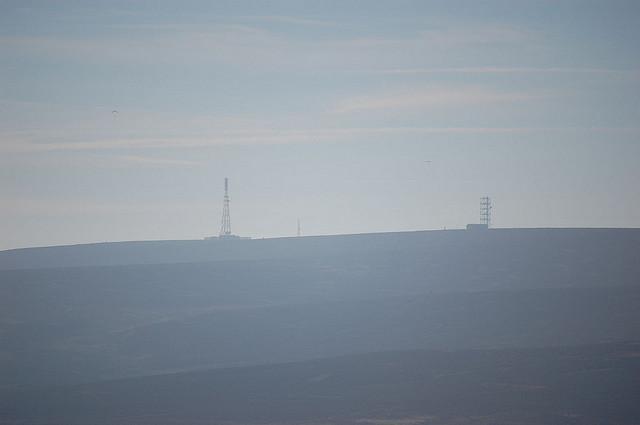Is this a beautiful Vista?
Keep it brief. Yes. Are there trees?
Give a very brief answer. No. Is this in the water or on land?
Write a very short answer. Water. Was this taken from a boat?
Keep it brief. No. What is the object on the left?
Be succinct. Oil rig. Is this a noisy environment?
Write a very short answer. No. What species is responsible for creating the objects in the background?
Answer briefly. Man. Is it night time?
Write a very short answer. No. Is it raining in the picture?
Concise answer only. No. What is in the background?
Keep it brief. Boats. Is there a train in this image?
Quick response, please. No. 